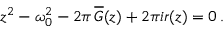Convert formula to latex. <formula><loc_0><loc_0><loc_500><loc_500>z ^ { 2 } - \omega _ { 0 } ^ { 2 } - 2 \pi \, \overline { G } ( z ) + 2 \pi i r ( z ) = 0 \, .</formula> 